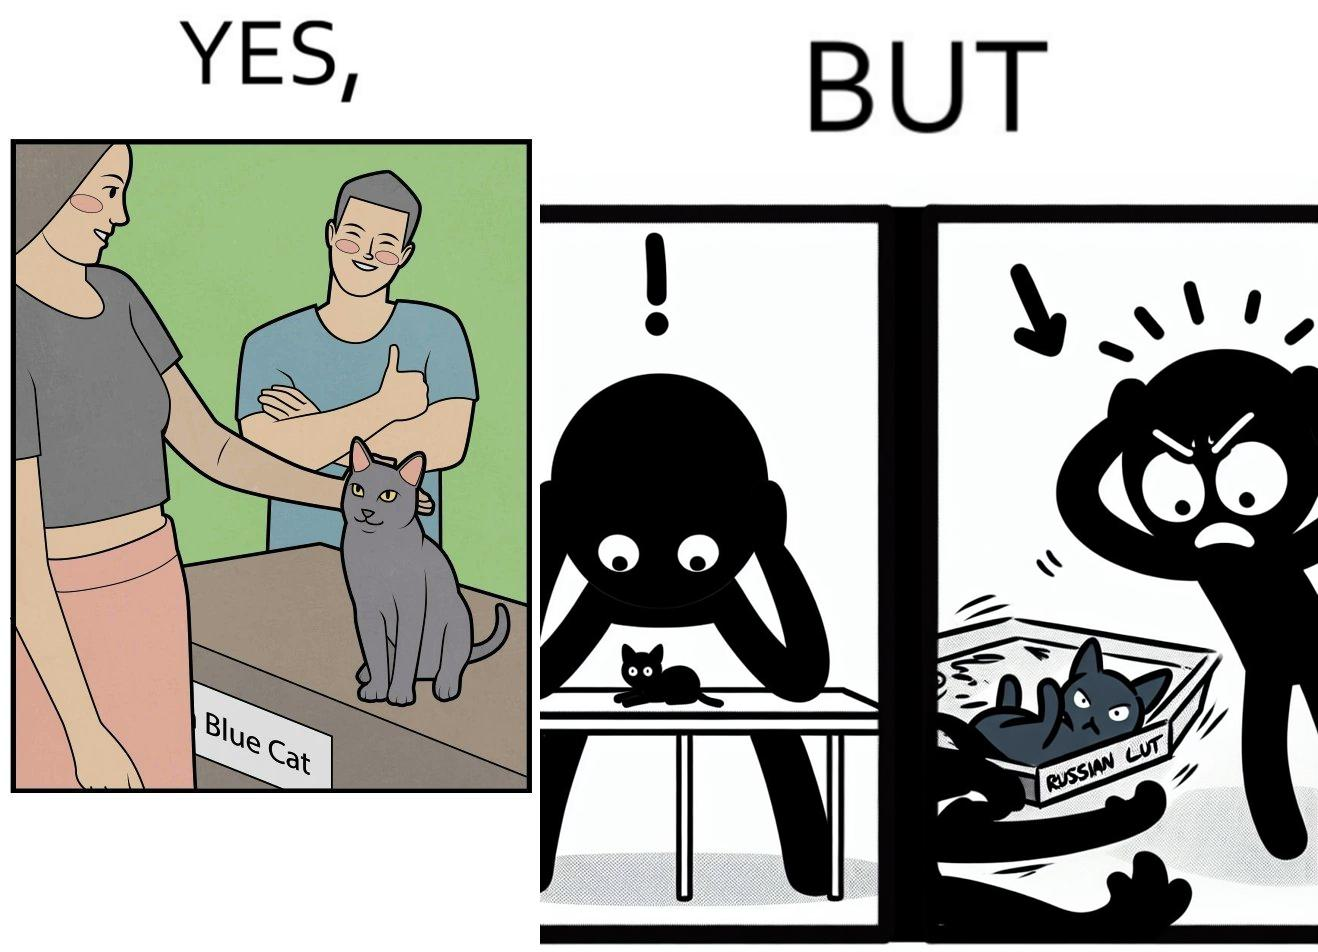Explain the humor or irony in this image. The image is confusing, as initially, when the label reads "Blue Cat", the people are happy and are petting tha cat, but as soon as one of them realizes that the entire text reads "Russian Blue Cat", they seem to worried, and one of them throws away the cat. For some reason, the word "Russian" is a trigger word for them. 